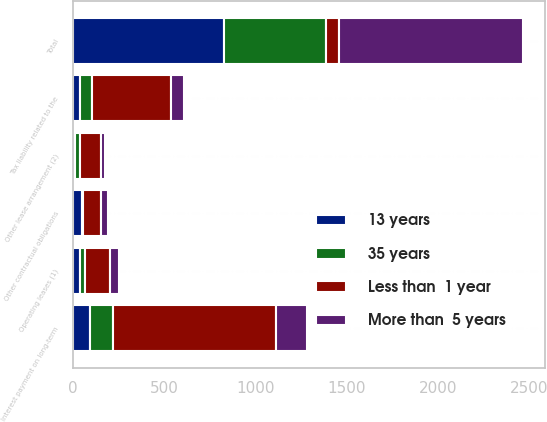Convert chart to OTSL. <chart><loc_0><loc_0><loc_500><loc_500><stacked_bar_chart><ecel><fcel>Operating leases (1)<fcel>Other lease arrangement (2)<fcel>Interest payment on long-term<fcel>Tax liability related to the<fcel>Other contractual obligations<fcel>Total<nl><fcel>Less than  1 year<fcel>139.7<fcel>112<fcel>892.9<fcel>431.2<fcel>94.8<fcel>68.5<nl><fcel>13 years<fcel>36.1<fcel>9.8<fcel>94<fcel>37.2<fcel>47.1<fcel>827.7<nl><fcel>More than  5 years<fcel>48.1<fcel>26.7<fcel>166.6<fcel>68.5<fcel>38.5<fcel>1010.1<nl><fcel>35 years<fcel>26.7<fcel>28.4<fcel>125.6<fcel>68.5<fcel>9.1<fcel>558.3<nl></chart> 